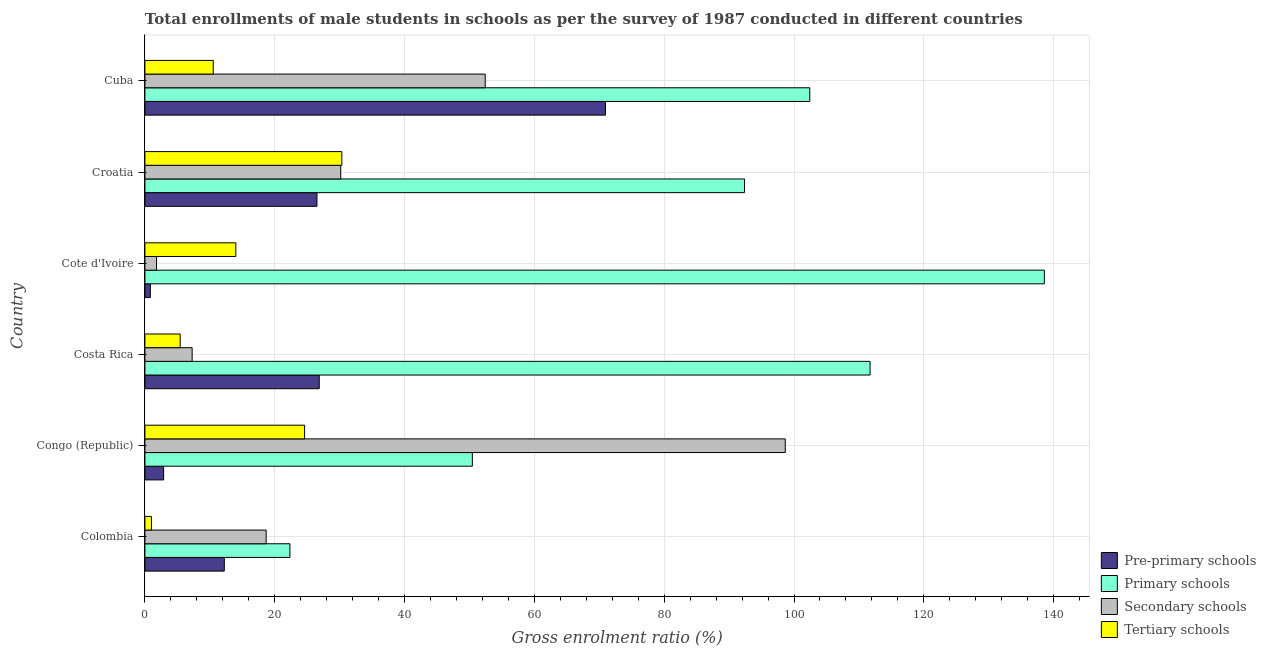How many different coloured bars are there?
Your answer should be very brief. 4. Are the number of bars per tick equal to the number of legend labels?
Provide a short and direct response. Yes. How many bars are there on the 5th tick from the top?
Provide a succinct answer. 4. What is the label of the 6th group of bars from the top?
Offer a terse response. Colombia. In how many cases, is the number of bars for a given country not equal to the number of legend labels?
Offer a very short reply. 0. What is the gross enrolment ratio(male) in primary schools in Costa Rica?
Provide a short and direct response. 111.72. Across all countries, what is the maximum gross enrolment ratio(male) in pre-primary schools?
Give a very brief answer. 70.95. Across all countries, what is the minimum gross enrolment ratio(male) in tertiary schools?
Give a very brief answer. 1. In which country was the gross enrolment ratio(male) in secondary schools maximum?
Provide a short and direct response. Congo (Republic). In which country was the gross enrolment ratio(male) in pre-primary schools minimum?
Ensure brevity in your answer.  Cote d'Ivoire. What is the total gross enrolment ratio(male) in secondary schools in the graph?
Provide a short and direct response. 208.99. What is the difference between the gross enrolment ratio(male) in tertiary schools in Congo (Republic) and that in Cote d'Ivoire?
Provide a succinct answer. 10.59. What is the difference between the gross enrolment ratio(male) in pre-primary schools in Croatia and the gross enrolment ratio(male) in tertiary schools in Cuba?
Make the answer very short. 15.98. What is the average gross enrolment ratio(male) in pre-primary schools per country?
Your response must be concise. 23.38. What is the difference between the gross enrolment ratio(male) in tertiary schools and gross enrolment ratio(male) in primary schools in Cote d'Ivoire?
Your answer should be compact. -124.56. What is the ratio of the gross enrolment ratio(male) in pre-primary schools in Croatia to that in Cuba?
Offer a terse response. 0.37. Is the gross enrolment ratio(male) in secondary schools in Colombia less than that in Croatia?
Your answer should be very brief. Yes. Is the difference between the gross enrolment ratio(male) in secondary schools in Costa Rica and Cuba greater than the difference between the gross enrolment ratio(male) in primary schools in Costa Rica and Cuba?
Keep it short and to the point. No. What is the difference between the highest and the second highest gross enrolment ratio(male) in primary schools?
Provide a short and direct response. 26.85. What is the difference between the highest and the lowest gross enrolment ratio(male) in primary schools?
Provide a short and direct response. 116.23. In how many countries, is the gross enrolment ratio(male) in secondary schools greater than the average gross enrolment ratio(male) in secondary schools taken over all countries?
Provide a succinct answer. 2. Is the sum of the gross enrolment ratio(male) in pre-primary schools in Cote d'Ivoire and Cuba greater than the maximum gross enrolment ratio(male) in secondary schools across all countries?
Your answer should be very brief. No. Is it the case that in every country, the sum of the gross enrolment ratio(male) in tertiary schools and gross enrolment ratio(male) in pre-primary schools is greater than the sum of gross enrolment ratio(male) in primary schools and gross enrolment ratio(male) in secondary schools?
Make the answer very short. No. What does the 1st bar from the top in Cote d'Ivoire represents?
Your answer should be very brief. Tertiary schools. What does the 4th bar from the bottom in Congo (Republic) represents?
Make the answer very short. Tertiary schools. Is it the case that in every country, the sum of the gross enrolment ratio(male) in pre-primary schools and gross enrolment ratio(male) in primary schools is greater than the gross enrolment ratio(male) in secondary schools?
Make the answer very short. No. How many bars are there?
Make the answer very short. 24. Are all the bars in the graph horizontal?
Give a very brief answer. Yes. Are the values on the major ticks of X-axis written in scientific E-notation?
Offer a terse response. No. Where does the legend appear in the graph?
Provide a short and direct response. Bottom right. What is the title of the graph?
Your answer should be very brief. Total enrollments of male students in schools as per the survey of 1987 conducted in different countries. Does "Water" appear as one of the legend labels in the graph?
Your answer should be compact. No. What is the Gross enrolment ratio (%) in Pre-primary schools in Colombia?
Your answer should be compact. 12.23. What is the Gross enrolment ratio (%) of Primary schools in Colombia?
Make the answer very short. 22.34. What is the Gross enrolment ratio (%) in Secondary schools in Colombia?
Keep it short and to the point. 18.68. What is the Gross enrolment ratio (%) of Tertiary schools in Colombia?
Offer a very short reply. 1. What is the Gross enrolment ratio (%) of Pre-primary schools in Congo (Republic)?
Provide a short and direct response. 2.88. What is the Gross enrolment ratio (%) in Primary schools in Congo (Republic)?
Keep it short and to the point. 50.44. What is the Gross enrolment ratio (%) of Secondary schools in Congo (Republic)?
Your response must be concise. 98.65. What is the Gross enrolment ratio (%) in Tertiary schools in Congo (Republic)?
Provide a succinct answer. 24.6. What is the Gross enrolment ratio (%) of Pre-primary schools in Costa Rica?
Offer a terse response. 26.85. What is the Gross enrolment ratio (%) of Primary schools in Costa Rica?
Offer a very short reply. 111.72. What is the Gross enrolment ratio (%) in Secondary schools in Costa Rica?
Provide a short and direct response. 7.27. What is the Gross enrolment ratio (%) in Tertiary schools in Costa Rica?
Your answer should be very brief. 5.43. What is the Gross enrolment ratio (%) of Pre-primary schools in Cote d'Ivoire?
Offer a terse response. 0.84. What is the Gross enrolment ratio (%) in Primary schools in Cote d'Ivoire?
Offer a very short reply. 138.57. What is the Gross enrolment ratio (%) in Secondary schools in Cote d'Ivoire?
Offer a very short reply. 1.79. What is the Gross enrolment ratio (%) of Tertiary schools in Cote d'Ivoire?
Ensure brevity in your answer.  14.01. What is the Gross enrolment ratio (%) of Pre-primary schools in Croatia?
Your response must be concise. 26.51. What is the Gross enrolment ratio (%) in Primary schools in Croatia?
Make the answer very short. 92.38. What is the Gross enrolment ratio (%) in Secondary schools in Croatia?
Your response must be concise. 30.17. What is the Gross enrolment ratio (%) in Tertiary schools in Croatia?
Give a very brief answer. 30.34. What is the Gross enrolment ratio (%) of Pre-primary schools in Cuba?
Make the answer very short. 70.95. What is the Gross enrolment ratio (%) in Primary schools in Cuba?
Your response must be concise. 102.43. What is the Gross enrolment ratio (%) of Secondary schools in Cuba?
Give a very brief answer. 52.43. What is the Gross enrolment ratio (%) of Tertiary schools in Cuba?
Ensure brevity in your answer.  10.53. Across all countries, what is the maximum Gross enrolment ratio (%) in Pre-primary schools?
Your answer should be compact. 70.95. Across all countries, what is the maximum Gross enrolment ratio (%) of Primary schools?
Provide a succinct answer. 138.57. Across all countries, what is the maximum Gross enrolment ratio (%) in Secondary schools?
Offer a terse response. 98.65. Across all countries, what is the maximum Gross enrolment ratio (%) in Tertiary schools?
Make the answer very short. 30.34. Across all countries, what is the minimum Gross enrolment ratio (%) in Pre-primary schools?
Keep it short and to the point. 0.84. Across all countries, what is the minimum Gross enrolment ratio (%) of Primary schools?
Your response must be concise. 22.34. Across all countries, what is the minimum Gross enrolment ratio (%) in Secondary schools?
Keep it short and to the point. 1.79. Across all countries, what is the minimum Gross enrolment ratio (%) in Tertiary schools?
Your answer should be compact. 1. What is the total Gross enrolment ratio (%) in Pre-primary schools in the graph?
Keep it short and to the point. 140.26. What is the total Gross enrolment ratio (%) in Primary schools in the graph?
Your answer should be very brief. 517.87. What is the total Gross enrolment ratio (%) of Secondary schools in the graph?
Your answer should be very brief. 208.99. What is the total Gross enrolment ratio (%) of Tertiary schools in the graph?
Your answer should be very brief. 85.91. What is the difference between the Gross enrolment ratio (%) of Pre-primary schools in Colombia and that in Congo (Republic)?
Offer a terse response. 9.35. What is the difference between the Gross enrolment ratio (%) in Primary schools in Colombia and that in Congo (Republic)?
Keep it short and to the point. -28.1. What is the difference between the Gross enrolment ratio (%) of Secondary schools in Colombia and that in Congo (Republic)?
Ensure brevity in your answer.  -79.97. What is the difference between the Gross enrolment ratio (%) in Tertiary schools in Colombia and that in Congo (Republic)?
Give a very brief answer. -23.59. What is the difference between the Gross enrolment ratio (%) in Pre-primary schools in Colombia and that in Costa Rica?
Provide a succinct answer. -14.62. What is the difference between the Gross enrolment ratio (%) of Primary schools in Colombia and that in Costa Rica?
Make the answer very short. -89.38. What is the difference between the Gross enrolment ratio (%) of Secondary schools in Colombia and that in Costa Rica?
Your answer should be compact. 11.4. What is the difference between the Gross enrolment ratio (%) in Tertiary schools in Colombia and that in Costa Rica?
Make the answer very short. -4.43. What is the difference between the Gross enrolment ratio (%) of Pre-primary schools in Colombia and that in Cote d'Ivoire?
Keep it short and to the point. 11.39. What is the difference between the Gross enrolment ratio (%) of Primary schools in Colombia and that in Cote d'Ivoire?
Offer a very short reply. -116.23. What is the difference between the Gross enrolment ratio (%) in Secondary schools in Colombia and that in Cote d'Ivoire?
Give a very brief answer. 16.89. What is the difference between the Gross enrolment ratio (%) of Tertiary schools in Colombia and that in Cote d'Ivoire?
Give a very brief answer. -13. What is the difference between the Gross enrolment ratio (%) in Pre-primary schools in Colombia and that in Croatia?
Make the answer very short. -14.28. What is the difference between the Gross enrolment ratio (%) of Primary schools in Colombia and that in Croatia?
Your answer should be very brief. -70.04. What is the difference between the Gross enrolment ratio (%) of Secondary schools in Colombia and that in Croatia?
Your answer should be very brief. -11.49. What is the difference between the Gross enrolment ratio (%) in Tertiary schools in Colombia and that in Croatia?
Your answer should be very brief. -29.33. What is the difference between the Gross enrolment ratio (%) in Pre-primary schools in Colombia and that in Cuba?
Your answer should be very brief. -58.72. What is the difference between the Gross enrolment ratio (%) in Primary schools in Colombia and that in Cuba?
Your answer should be very brief. -80.09. What is the difference between the Gross enrolment ratio (%) in Secondary schools in Colombia and that in Cuba?
Keep it short and to the point. -33.75. What is the difference between the Gross enrolment ratio (%) in Tertiary schools in Colombia and that in Cuba?
Your answer should be very brief. -9.52. What is the difference between the Gross enrolment ratio (%) of Pre-primary schools in Congo (Republic) and that in Costa Rica?
Your answer should be very brief. -23.97. What is the difference between the Gross enrolment ratio (%) in Primary schools in Congo (Republic) and that in Costa Rica?
Offer a terse response. -61.27. What is the difference between the Gross enrolment ratio (%) in Secondary schools in Congo (Republic) and that in Costa Rica?
Offer a terse response. 91.38. What is the difference between the Gross enrolment ratio (%) of Tertiary schools in Congo (Republic) and that in Costa Rica?
Ensure brevity in your answer.  19.17. What is the difference between the Gross enrolment ratio (%) of Pre-primary schools in Congo (Republic) and that in Cote d'Ivoire?
Offer a very short reply. 2.05. What is the difference between the Gross enrolment ratio (%) in Primary schools in Congo (Republic) and that in Cote d'Ivoire?
Provide a succinct answer. -88.13. What is the difference between the Gross enrolment ratio (%) of Secondary schools in Congo (Republic) and that in Cote d'Ivoire?
Your answer should be compact. 96.86. What is the difference between the Gross enrolment ratio (%) of Tertiary schools in Congo (Republic) and that in Cote d'Ivoire?
Ensure brevity in your answer.  10.59. What is the difference between the Gross enrolment ratio (%) in Pre-primary schools in Congo (Republic) and that in Croatia?
Your answer should be compact. -23.63. What is the difference between the Gross enrolment ratio (%) in Primary schools in Congo (Republic) and that in Croatia?
Offer a terse response. -41.93. What is the difference between the Gross enrolment ratio (%) in Secondary schools in Congo (Republic) and that in Croatia?
Your answer should be compact. 68.49. What is the difference between the Gross enrolment ratio (%) of Tertiary schools in Congo (Republic) and that in Croatia?
Ensure brevity in your answer.  -5.74. What is the difference between the Gross enrolment ratio (%) of Pre-primary schools in Congo (Republic) and that in Cuba?
Your answer should be compact. -68.07. What is the difference between the Gross enrolment ratio (%) of Primary schools in Congo (Republic) and that in Cuba?
Ensure brevity in your answer.  -51.99. What is the difference between the Gross enrolment ratio (%) of Secondary schools in Congo (Republic) and that in Cuba?
Provide a succinct answer. 46.23. What is the difference between the Gross enrolment ratio (%) of Tertiary schools in Congo (Republic) and that in Cuba?
Your answer should be very brief. 14.07. What is the difference between the Gross enrolment ratio (%) in Pre-primary schools in Costa Rica and that in Cote d'Ivoire?
Provide a succinct answer. 26.02. What is the difference between the Gross enrolment ratio (%) in Primary schools in Costa Rica and that in Cote d'Ivoire?
Offer a very short reply. -26.85. What is the difference between the Gross enrolment ratio (%) of Secondary schools in Costa Rica and that in Cote d'Ivoire?
Your answer should be compact. 5.49. What is the difference between the Gross enrolment ratio (%) of Tertiary schools in Costa Rica and that in Cote d'Ivoire?
Your answer should be very brief. -8.58. What is the difference between the Gross enrolment ratio (%) in Pre-primary schools in Costa Rica and that in Croatia?
Your response must be concise. 0.35. What is the difference between the Gross enrolment ratio (%) of Primary schools in Costa Rica and that in Croatia?
Give a very brief answer. 19.34. What is the difference between the Gross enrolment ratio (%) in Secondary schools in Costa Rica and that in Croatia?
Offer a terse response. -22.89. What is the difference between the Gross enrolment ratio (%) in Tertiary schools in Costa Rica and that in Croatia?
Keep it short and to the point. -24.91. What is the difference between the Gross enrolment ratio (%) in Pre-primary schools in Costa Rica and that in Cuba?
Offer a very short reply. -44.1. What is the difference between the Gross enrolment ratio (%) of Primary schools in Costa Rica and that in Cuba?
Your answer should be very brief. 9.29. What is the difference between the Gross enrolment ratio (%) of Secondary schools in Costa Rica and that in Cuba?
Ensure brevity in your answer.  -45.15. What is the difference between the Gross enrolment ratio (%) of Tertiary schools in Costa Rica and that in Cuba?
Your answer should be very brief. -5.09. What is the difference between the Gross enrolment ratio (%) of Pre-primary schools in Cote d'Ivoire and that in Croatia?
Offer a terse response. -25.67. What is the difference between the Gross enrolment ratio (%) of Primary schools in Cote d'Ivoire and that in Croatia?
Ensure brevity in your answer.  46.19. What is the difference between the Gross enrolment ratio (%) of Secondary schools in Cote d'Ivoire and that in Croatia?
Offer a very short reply. -28.38. What is the difference between the Gross enrolment ratio (%) in Tertiary schools in Cote d'Ivoire and that in Croatia?
Your response must be concise. -16.33. What is the difference between the Gross enrolment ratio (%) in Pre-primary schools in Cote d'Ivoire and that in Cuba?
Provide a succinct answer. -70.12. What is the difference between the Gross enrolment ratio (%) of Primary schools in Cote d'Ivoire and that in Cuba?
Provide a short and direct response. 36.14. What is the difference between the Gross enrolment ratio (%) of Secondary schools in Cote d'Ivoire and that in Cuba?
Provide a succinct answer. -50.64. What is the difference between the Gross enrolment ratio (%) of Tertiary schools in Cote d'Ivoire and that in Cuba?
Make the answer very short. 3.48. What is the difference between the Gross enrolment ratio (%) in Pre-primary schools in Croatia and that in Cuba?
Make the answer very short. -44.45. What is the difference between the Gross enrolment ratio (%) in Primary schools in Croatia and that in Cuba?
Keep it short and to the point. -10.05. What is the difference between the Gross enrolment ratio (%) of Secondary schools in Croatia and that in Cuba?
Your response must be concise. -22.26. What is the difference between the Gross enrolment ratio (%) in Tertiary schools in Croatia and that in Cuba?
Make the answer very short. 19.81. What is the difference between the Gross enrolment ratio (%) in Pre-primary schools in Colombia and the Gross enrolment ratio (%) in Primary schools in Congo (Republic)?
Offer a terse response. -38.21. What is the difference between the Gross enrolment ratio (%) in Pre-primary schools in Colombia and the Gross enrolment ratio (%) in Secondary schools in Congo (Republic)?
Your answer should be very brief. -86.42. What is the difference between the Gross enrolment ratio (%) of Pre-primary schools in Colombia and the Gross enrolment ratio (%) of Tertiary schools in Congo (Republic)?
Your response must be concise. -12.37. What is the difference between the Gross enrolment ratio (%) in Primary schools in Colombia and the Gross enrolment ratio (%) in Secondary schools in Congo (Republic)?
Give a very brief answer. -76.31. What is the difference between the Gross enrolment ratio (%) of Primary schools in Colombia and the Gross enrolment ratio (%) of Tertiary schools in Congo (Republic)?
Provide a succinct answer. -2.26. What is the difference between the Gross enrolment ratio (%) in Secondary schools in Colombia and the Gross enrolment ratio (%) in Tertiary schools in Congo (Republic)?
Your response must be concise. -5.92. What is the difference between the Gross enrolment ratio (%) of Pre-primary schools in Colombia and the Gross enrolment ratio (%) of Primary schools in Costa Rica?
Your response must be concise. -99.49. What is the difference between the Gross enrolment ratio (%) in Pre-primary schools in Colombia and the Gross enrolment ratio (%) in Secondary schools in Costa Rica?
Provide a succinct answer. 4.96. What is the difference between the Gross enrolment ratio (%) of Pre-primary schools in Colombia and the Gross enrolment ratio (%) of Tertiary schools in Costa Rica?
Your answer should be very brief. 6.8. What is the difference between the Gross enrolment ratio (%) in Primary schools in Colombia and the Gross enrolment ratio (%) in Secondary schools in Costa Rica?
Give a very brief answer. 15.06. What is the difference between the Gross enrolment ratio (%) of Primary schools in Colombia and the Gross enrolment ratio (%) of Tertiary schools in Costa Rica?
Offer a very short reply. 16.91. What is the difference between the Gross enrolment ratio (%) of Secondary schools in Colombia and the Gross enrolment ratio (%) of Tertiary schools in Costa Rica?
Offer a very short reply. 13.25. What is the difference between the Gross enrolment ratio (%) in Pre-primary schools in Colombia and the Gross enrolment ratio (%) in Primary schools in Cote d'Ivoire?
Your answer should be very brief. -126.34. What is the difference between the Gross enrolment ratio (%) of Pre-primary schools in Colombia and the Gross enrolment ratio (%) of Secondary schools in Cote d'Ivoire?
Make the answer very short. 10.44. What is the difference between the Gross enrolment ratio (%) in Pre-primary schools in Colombia and the Gross enrolment ratio (%) in Tertiary schools in Cote d'Ivoire?
Offer a terse response. -1.78. What is the difference between the Gross enrolment ratio (%) in Primary schools in Colombia and the Gross enrolment ratio (%) in Secondary schools in Cote d'Ivoire?
Your answer should be compact. 20.55. What is the difference between the Gross enrolment ratio (%) of Primary schools in Colombia and the Gross enrolment ratio (%) of Tertiary schools in Cote d'Ivoire?
Make the answer very short. 8.33. What is the difference between the Gross enrolment ratio (%) in Secondary schools in Colombia and the Gross enrolment ratio (%) in Tertiary schools in Cote d'Ivoire?
Provide a short and direct response. 4.67. What is the difference between the Gross enrolment ratio (%) of Pre-primary schools in Colombia and the Gross enrolment ratio (%) of Primary schools in Croatia?
Keep it short and to the point. -80.15. What is the difference between the Gross enrolment ratio (%) in Pre-primary schools in Colombia and the Gross enrolment ratio (%) in Secondary schools in Croatia?
Your response must be concise. -17.94. What is the difference between the Gross enrolment ratio (%) of Pre-primary schools in Colombia and the Gross enrolment ratio (%) of Tertiary schools in Croatia?
Offer a very short reply. -18.11. What is the difference between the Gross enrolment ratio (%) in Primary schools in Colombia and the Gross enrolment ratio (%) in Secondary schools in Croatia?
Give a very brief answer. -7.83. What is the difference between the Gross enrolment ratio (%) in Primary schools in Colombia and the Gross enrolment ratio (%) in Tertiary schools in Croatia?
Your answer should be very brief. -8. What is the difference between the Gross enrolment ratio (%) of Secondary schools in Colombia and the Gross enrolment ratio (%) of Tertiary schools in Croatia?
Give a very brief answer. -11.66. What is the difference between the Gross enrolment ratio (%) of Pre-primary schools in Colombia and the Gross enrolment ratio (%) of Primary schools in Cuba?
Keep it short and to the point. -90.2. What is the difference between the Gross enrolment ratio (%) of Pre-primary schools in Colombia and the Gross enrolment ratio (%) of Secondary schools in Cuba?
Your answer should be very brief. -40.2. What is the difference between the Gross enrolment ratio (%) in Pre-primary schools in Colombia and the Gross enrolment ratio (%) in Tertiary schools in Cuba?
Your answer should be compact. 1.7. What is the difference between the Gross enrolment ratio (%) in Primary schools in Colombia and the Gross enrolment ratio (%) in Secondary schools in Cuba?
Make the answer very short. -30.09. What is the difference between the Gross enrolment ratio (%) in Primary schools in Colombia and the Gross enrolment ratio (%) in Tertiary schools in Cuba?
Your answer should be compact. 11.81. What is the difference between the Gross enrolment ratio (%) of Secondary schools in Colombia and the Gross enrolment ratio (%) of Tertiary schools in Cuba?
Ensure brevity in your answer.  8.15. What is the difference between the Gross enrolment ratio (%) of Pre-primary schools in Congo (Republic) and the Gross enrolment ratio (%) of Primary schools in Costa Rica?
Offer a terse response. -108.83. What is the difference between the Gross enrolment ratio (%) of Pre-primary schools in Congo (Republic) and the Gross enrolment ratio (%) of Secondary schools in Costa Rica?
Keep it short and to the point. -4.39. What is the difference between the Gross enrolment ratio (%) of Pre-primary schools in Congo (Republic) and the Gross enrolment ratio (%) of Tertiary schools in Costa Rica?
Ensure brevity in your answer.  -2.55. What is the difference between the Gross enrolment ratio (%) of Primary schools in Congo (Republic) and the Gross enrolment ratio (%) of Secondary schools in Costa Rica?
Provide a short and direct response. 43.17. What is the difference between the Gross enrolment ratio (%) in Primary schools in Congo (Republic) and the Gross enrolment ratio (%) in Tertiary schools in Costa Rica?
Give a very brief answer. 45.01. What is the difference between the Gross enrolment ratio (%) of Secondary schools in Congo (Republic) and the Gross enrolment ratio (%) of Tertiary schools in Costa Rica?
Your answer should be very brief. 93.22. What is the difference between the Gross enrolment ratio (%) in Pre-primary schools in Congo (Republic) and the Gross enrolment ratio (%) in Primary schools in Cote d'Ivoire?
Provide a short and direct response. -135.69. What is the difference between the Gross enrolment ratio (%) in Pre-primary schools in Congo (Republic) and the Gross enrolment ratio (%) in Secondary schools in Cote d'Ivoire?
Your answer should be very brief. 1.09. What is the difference between the Gross enrolment ratio (%) of Pre-primary schools in Congo (Republic) and the Gross enrolment ratio (%) of Tertiary schools in Cote d'Ivoire?
Make the answer very short. -11.13. What is the difference between the Gross enrolment ratio (%) of Primary schools in Congo (Republic) and the Gross enrolment ratio (%) of Secondary schools in Cote d'Ivoire?
Your response must be concise. 48.65. What is the difference between the Gross enrolment ratio (%) of Primary schools in Congo (Republic) and the Gross enrolment ratio (%) of Tertiary schools in Cote d'Ivoire?
Offer a terse response. 36.44. What is the difference between the Gross enrolment ratio (%) in Secondary schools in Congo (Republic) and the Gross enrolment ratio (%) in Tertiary schools in Cote d'Ivoire?
Offer a very short reply. 84.65. What is the difference between the Gross enrolment ratio (%) in Pre-primary schools in Congo (Republic) and the Gross enrolment ratio (%) in Primary schools in Croatia?
Ensure brevity in your answer.  -89.5. What is the difference between the Gross enrolment ratio (%) in Pre-primary schools in Congo (Republic) and the Gross enrolment ratio (%) in Secondary schools in Croatia?
Give a very brief answer. -27.29. What is the difference between the Gross enrolment ratio (%) in Pre-primary schools in Congo (Republic) and the Gross enrolment ratio (%) in Tertiary schools in Croatia?
Make the answer very short. -27.46. What is the difference between the Gross enrolment ratio (%) in Primary schools in Congo (Republic) and the Gross enrolment ratio (%) in Secondary schools in Croatia?
Your response must be concise. 20.27. What is the difference between the Gross enrolment ratio (%) in Primary schools in Congo (Republic) and the Gross enrolment ratio (%) in Tertiary schools in Croatia?
Ensure brevity in your answer.  20.1. What is the difference between the Gross enrolment ratio (%) of Secondary schools in Congo (Republic) and the Gross enrolment ratio (%) of Tertiary schools in Croatia?
Keep it short and to the point. 68.31. What is the difference between the Gross enrolment ratio (%) of Pre-primary schools in Congo (Republic) and the Gross enrolment ratio (%) of Primary schools in Cuba?
Ensure brevity in your answer.  -99.55. What is the difference between the Gross enrolment ratio (%) in Pre-primary schools in Congo (Republic) and the Gross enrolment ratio (%) in Secondary schools in Cuba?
Provide a short and direct response. -49.55. What is the difference between the Gross enrolment ratio (%) in Pre-primary schools in Congo (Republic) and the Gross enrolment ratio (%) in Tertiary schools in Cuba?
Ensure brevity in your answer.  -7.65. What is the difference between the Gross enrolment ratio (%) of Primary schools in Congo (Republic) and the Gross enrolment ratio (%) of Secondary schools in Cuba?
Provide a succinct answer. -1.98. What is the difference between the Gross enrolment ratio (%) of Primary schools in Congo (Republic) and the Gross enrolment ratio (%) of Tertiary schools in Cuba?
Your response must be concise. 39.92. What is the difference between the Gross enrolment ratio (%) of Secondary schools in Congo (Republic) and the Gross enrolment ratio (%) of Tertiary schools in Cuba?
Provide a succinct answer. 88.13. What is the difference between the Gross enrolment ratio (%) of Pre-primary schools in Costa Rica and the Gross enrolment ratio (%) of Primary schools in Cote d'Ivoire?
Ensure brevity in your answer.  -111.72. What is the difference between the Gross enrolment ratio (%) of Pre-primary schools in Costa Rica and the Gross enrolment ratio (%) of Secondary schools in Cote d'Ivoire?
Your answer should be very brief. 25.06. What is the difference between the Gross enrolment ratio (%) of Pre-primary schools in Costa Rica and the Gross enrolment ratio (%) of Tertiary schools in Cote d'Ivoire?
Ensure brevity in your answer.  12.85. What is the difference between the Gross enrolment ratio (%) of Primary schools in Costa Rica and the Gross enrolment ratio (%) of Secondary schools in Cote d'Ivoire?
Keep it short and to the point. 109.93. What is the difference between the Gross enrolment ratio (%) of Primary schools in Costa Rica and the Gross enrolment ratio (%) of Tertiary schools in Cote d'Ivoire?
Offer a very short reply. 97.71. What is the difference between the Gross enrolment ratio (%) in Secondary schools in Costa Rica and the Gross enrolment ratio (%) in Tertiary schools in Cote d'Ivoire?
Offer a very short reply. -6.73. What is the difference between the Gross enrolment ratio (%) in Pre-primary schools in Costa Rica and the Gross enrolment ratio (%) in Primary schools in Croatia?
Provide a short and direct response. -65.52. What is the difference between the Gross enrolment ratio (%) in Pre-primary schools in Costa Rica and the Gross enrolment ratio (%) in Secondary schools in Croatia?
Offer a terse response. -3.31. What is the difference between the Gross enrolment ratio (%) of Pre-primary schools in Costa Rica and the Gross enrolment ratio (%) of Tertiary schools in Croatia?
Offer a very short reply. -3.48. What is the difference between the Gross enrolment ratio (%) of Primary schools in Costa Rica and the Gross enrolment ratio (%) of Secondary schools in Croatia?
Your answer should be compact. 81.55. What is the difference between the Gross enrolment ratio (%) of Primary schools in Costa Rica and the Gross enrolment ratio (%) of Tertiary schools in Croatia?
Ensure brevity in your answer.  81.38. What is the difference between the Gross enrolment ratio (%) of Secondary schools in Costa Rica and the Gross enrolment ratio (%) of Tertiary schools in Croatia?
Your response must be concise. -23.06. What is the difference between the Gross enrolment ratio (%) in Pre-primary schools in Costa Rica and the Gross enrolment ratio (%) in Primary schools in Cuba?
Offer a terse response. -75.57. What is the difference between the Gross enrolment ratio (%) of Pre-primary schools in Costa Rica and the Gross enrolment ratio (%) of Secondary schools in Cuba?
Provide a short and direct response. -25.57. What is the difference between the Gross enrolment ratio (%) of Pre-primary schools in Costa Rica and the Gross enrolment ratio (%) of Tertiary schools in Cuba?
Ensure brevity in your answer.  16.33. What is the difference between the Gross enrolment ratio (%) of Primary schools in Costa Rica and the Gross enrolment ratio (%) of Secondary schools in Cuba?
Your answer should be compact. 59.29. What is the difference between the Gross enrolment ratio (%) in Primary schools in Costa Rica and the Gross enrolment ratio (%) in Tertiary schools in Cuba?
Keep it short and to the point. 101.19. What is the difference between the Gross enrolment ratio (%) in Secondary schools in Costa Rica and the Gross enrolment ratio (%) in Tertiary schools in Cuba?
Your answer should be very brief. -3.25. What is the difference between the Gross enrolment ratio (%) of Pre-primary schools in Cote d'Ivoire and the Gross enrolment ratio (%) of Primary schools in Croatia?
Your response must be concise. -91.54. What is the difference between the Gross enrolment ratio (%) of Pre-primary schools in Cote d'Ivoire and the Gross enrolment ratio (%) of Secondary schools in Croatia?
Offer a terse response. -29.33. What is the difference between the Gross enrolment ratio (%) of Pre-primary schools in Cote d'Ivoire and the Gross enrolment ratio (%) of Tertiary schools in Croatia?
Provide a short and direct response. -29.5. What is the difference between the Gross enrolment ratio (%) in Primary schools in Cote d'Ivoire and the Gross enrolment ratio (%) in Secondary schools in Croatia?
Make the answer very short. 108.4. What is the difference between the Gross enrolment ratio (%) of Primary schools in Cote d'Ivoire and the Gross enrolment ratio (%) of Tertiary schools in Croatia?
Your answer should be very brief. 108.23. What is the difference between the Gross enrolment ratio (%) in Secondary schools in Cote d'Ivoire and the Gross enrolment ratio (%) in Tertiary schools in Croatia?
Ensure brevity in your answer.  -28.55. What is the difference between the Gross enrolment ratio (%) of Pre-primary schools in Cote d'Ivoire and the Gross enrolment ratio (%) of Primary schools in Cuba?
Keep it short and to the point. -101.59. What is the difference between the Gross enrolment ratio (%) of Pre-primary schools in Cote d'Ivoire and the Gross enrolment ratio (%) of Secondary schools in Cuba?
Offer a terse response. -51.59. What is the difference between the Gross enrolment ratio (%) in Pre-primary schools in Cote d'Ivoire and the Gross enrolment ratio (%) in Tertiary schools in Cuba?
Ensure brevity in your answer.  -9.69. What is the difference between the Gross enrolment ratio (%) in Primary schools in Cote d'Ivoire and the Gross enrolment ratio (%) in Secondary schools in Cuba?
Your answer should be very brief. 86.14. What is the difference between the Gross enrolment ratio (%) of Primary schools in Cote d'Ivoire and the Gross enrolment ratio (%) of Tertiary schools in Cuba?
Offer a terse response. 128.04. What is the difference between the Gross enrolment ratio (%) of Secondary schools in Cote d'Ivoire and the Gross enrolment ratio (%) of Tertiary schools in Cuba?
Your response must be concise. -8.74. What is the difference between the Gross enrolment ratio (%) in Pre-primary schools in Croatia and the Gross enrolment ratio (%) in Primary schools in Cuba?
Provide a short and direct response. -75.92. What is the difference between the Gross enrolment ratio (%) of Pre-primary schools in Croatia and the Gross enrolment ratio (%) of Secondary schools in Cuba?
Offer a terse response. -25.92. What is the difference between the Gross enrolment ratio (%) in Pre-primary schools in Croatia and the Gross enrolment ratio (%) in Tertiary schools in Cuba?
Ensure brevity in your answer.  15.98. What is the difference between the Gross enrolment ratio (%) in Primary schools in Croatia and the Gross enrolment ratio (%) in Secondary schools in Cuba?
Ensure brevity in your answer.  39.95. What is the difference between the Gross enrolment ratio (%) of Primary schools in Croatia and the Gross enrolment ratio (%) of Tertiary schools in Cuba?
Your answer should be compact. 81.85. What is the difference between the Gross enrolment ratio (%) of Secondary schools in Croatia and the Gross enrolment ratio (%) of Tertiary schools in Cuba?
Provide a succinct answer. 19.64. What is the average Gross enrolment ratio (%) in Pre-primary schools per country?
Offer a terse response. 23.38. What is the average Gross enrolment ratio (%) of Primary schools per country?
Give a very brief answer. 86.31. What is the average Gross enrolment ratio (%) of Secondary schools per country?
Your response must be concise. 34.83. What is the average Gross enrolment ratio (%) in Tertiary schools per country?
Provide a succinct answer. 14.32. What is the difference between the Gross enrolment ratio (%) in Pre-primary schools and Gross enrolment ratio (%) in Primary schools in Colombia?
Your answer should be compact. -10.11. What is the difference between the Gross enrolment ratio (%) of Pre-primary schools and Gross enrolment ratio (%) of Secondary schools in Colombia?
Your answer should be compact. -6.45. What is the difference between the Gross enrolment ratio (%) of Pre-primary schools and Gross enrolment ratio (%) of Tertiary schools in Colombia?
Your answer should be compact. 11.23. What is the difference between the Gross enrolment ratio (%) of Primary schools and Gross enrolment ratio (%) of Secondary schools in Colombia?
Offer a very short reply. 3.66. What is the difference between the Gross enrolment ratio (%) in Primary schools and Gross enrolment ratio (%) in Tertiary schools in Colombia?
Offer a terse response. 21.33. What is the difference between the Gross enrolment ratio (%) of Secondary schools and Gross enrolment ratio (%) of Tertiary schools in Colombia?
Your response must be concise. 17.67. What is the difference between the Gross enrolment ratio (%) of Pre-primary schools and Gross enrolment ratio (%) of Primary schools in Congo (Republic)?
Offer a terse response. -47.56. What is the difference between the Gross enrolment ratio (%) of Pre-primary schools and Gross enrolment ratio (%) of Secondary schools in Congo (Republic)?
Provide a succinct answer. -95.77. What is the difference between the Gross enrolment ratio (%) in Pre-primary schools and Gross enrolment ratio (%) in Tertiary schools in Congo (Republic)?
Offer a terse response. -21.72. What is the difference between the Gross enrolment ratio (%) of Primary schools and Gross enrolment ratio (%) of Secondary schools in Congo (Republic)?
Provide a short and direct response. -48.21. What is the difference between the Gross enrolment ratio (%) in Primary schools and Gross enrolment ratio (%) in Tertiary schools in Congo (Republic)?
Your answer should be compact. 25.84. What is the difference between the Gross enrolment ratio (%) of Secondary schools and Gross enrolment ratio (%) of Tertiary schools in Congo (Republic)?
Give a very brief answer. 74.05. What is the difference between the Gross enrolment ratio (%) in Pre-primary schools and Gross enrolment ratio (%) in Primary schools in Costa Rica?
Provide a short and direct response. -84.86. What is the difference between the Gross enrolment ratio (%) of Pre-primary schools and Gross enrolment ratio (%) of Secondary schools in Costa Rica?
Your response must be concise. 19.58. What is the difference between the Gross enrolment ratio (%) in Pre-primary schools and Gross enrolment ratio (%) in Tertiary schools in Costa Rica?
Keep it short and to the point. 21.42. What is the difference between the Gross enrolment ratio (%) of Primary schools and Gross enrolment ratio (%) of Secondary schools in Costa Rica?
Provide a succinct answer. 104.44. What is the difference between the Gross enrolment ratio (%) in Primary schools and Gross enrolment ratio (%) in Tertiary schools in Costa Rica?
Provide a short and direct response. 106.28. What is the difference between the Gross enrolment ratio (%) of Secondary schools and Gross enrolment ratio (%) of Tertiary schools in Costa Rica?
Offer a very short reply. 1.84. What is the difference between the Gross enrolment ratio (%) of Pre-primary schools and Gross enrolment ratio (%) of Primary schools in Cote d'Ivoire?
Offer a very short reply. -137.73. What is the difference between the Gross enrolment ratio (%) in Pre-primary schools and Gross enrolment ratio (%) in Secondary schools in Cote d'Ivoire?
Your response must be concise. -0.95. What is the difference between the Gross enrolment ratio (%) in Pre-primary schools and Gross enrolment ratio (%) in Tertiary schools in Cote d'Ivoire?
Ensure brevity in your answer.  -13.17. What is the difference between the Gross enrolment ratio (%) of Primary schools and Gross enrolment ratio (%) of Secondary schools in Cote d'Ivoire?
Give a very brief answer. 136.78. What is the difference between the Gross enrolment ratio (%) of Primary schools and Gross enrolment ratio (%) of Tertiary schools in Cote d'Ivoire?
Make the answer very short. 124.56. What is the difference between the Gross enrolment ratio (%) in Secondary schools and Gross enrolment ratio (%) in Tertiary schools in Cote d'Ivoire?
Provide a succinct answer. -12.22. What is the difference between the Gross enrolment ratio (%) in Pre-primary schools and Gross enrolment ratio (%) in Primary schools in Croatia?
Provide a short and direct response. -65.87. What is the difference between the Gross enrolment ratio (%) of Pre-primary schools and Gross enrolment ratio (%) of Secondary schools in Croatia?
Provide a succinct answer. -3.66. What is the difference between the Gross enrolment ratio (%) in Pre-primary schools and Gross enrolment ratio (%) in Tertiary schools in Croatia?
Make the answer very short. -3.83. What is the difference between the Gross enrolment ratio (%) in Primary schools and Gross enrolment ratio (%) in Secondary schools in Croatia?
Provide a short and direct response. 62.21. What is the difference between the Gross enrolment ratio (%) of Primary schools and Gross enrolment ratio (%) of Tertiary schools in Croatia?
Offer a terse response. 62.04. What is the difference between the Gross enrolment ratio (%) in Secondary schools and Gross enrolment ratio (%) in Tertiary schools in Croatia?
Provide a succinct answer. -0.17. What is the difference between the Gross enrolment ratio (%) in Pre-primary schools and Gross enrolment ratio (%) in Primary schools in Cuba?
Ensure brevity in your answer.  -31.47. What is the difference between the Gross enrolment ratio (%) in Pre-primary schools and Gross enrolment ratio (%) in Secondary schools in Cuba?
Your answer should be compact. 18.53. What is the difference between the Gross enrolment ratio (%) in Pre-primary schools and Gross enrolment ratio (%) in Tertiary schools in Cuba?
Provide a short and direct response. 60.43. What is the difference between the Gross enrolment ratio (%) in Primary schools and Gross enrolment ratio (%) in Secondary schools in Cuba?
Provide a succinct answer. 50. What is the difference between the Gross enrolment ratio (%) in Primary schools and Gross enrolment ratio (%) in Tertiary schools in Cuba?
Give a very brief answer. 91.9. What is the difference between the Gross enrolment ratio (%) in Secondary schools and Gross enrolment ratio (%) in Tertiary schools in Cuba?
Your answer should be very brief. 41.9. What is the ratio of the Gross enrolment ratio (%) in Pre-primary schools in Colombia to that in Congo (Republic)?
Provide a short and direct response. 4.25. What is the ratio of the Gross enrolment ratio (%) in Primary schools in Colombia to that in Congo (Republic)?
Keep it short and to the point. 0.44. What is the ratio of the Gross enrolment ratio (%) of Secondary schools in Colombia to that in Congo (Republic)?
Provide a short and direct response. 0.19. What is the ratio of the Gross enrolment ratio (%) of Tertiary schools in Colombia to that in Congo (Republic)?
Provide a short and direct response. 0.04. What is the ratio of the Gross enrolment ratio (%) of Pre-primary schools in Colombia to that in Costa Rica?
Provide a short and direct response. 0.46. What is the ratio of the Gross enrolment ratio (%) of Secondary schools in Colombia to that in Costa Rica?
Make the answer very short. 2.57. What is the ratio of the Gross enrolment ratio (%) of Tertiary schools in Colombia to that in Costa Rica?
Your answer should be very brief. 0.18. What is the ratio of the Gross enrolment ratio (%) in Pre-primary schools in Colombia to that in Cote d'Ivoire?
Ensure brevity in your answer.  14.63. What is the ratio of the Gross enrolment ratio (%) in Primary schools in Colombia to that in Cote d'Ivoire?
Offer a very short reply. 0.16. What is the ratio of the Gross enrolment ratio (%) of Secondary schools in Colombia to that in Cote d'Ivoire?
Your answer should be very brief. 10.44. What is the ratio of the Gross enrolment ratio (%) in Tertiary schools in Colombia to that in Cote d'Ivoire?
Ensure brevity in your answer.  0.07. What is the ratio of the Gross enrolment ratio (%) of Pre-primary schools in Colombia to that in Croatia?
Give a very brief answer. 0.46. What is the ratio of the Gross enrolment ratio (%) of Primary schools in Colombia to that in Croatia?
Provide a succinct answer. 0.24. What is the ratio of the Gross enrolment ratio (%) of Secondary schools in Colombia to that in Croatia?
Give a very brief answer. 0.62. What is the ratio of the Gross enrolment ratio (%) of Tertiary schools in Colombia to that in Croatia?
Give a very brief answer. 0.03. What is the ratio of the Gross enrolment ratio (%) of Pre-primary schools in Colombia to that in Cuba?
Your response must be concise. 0.17. What is the ratio of the Gross enrolment ratio (%) in Primary schools in Colombia to that in Cuba?
Give a very brief answer. 0.22. What is the ratio of the Gross enrolment ratio (%) in Secondary schools in Colombia to that in Cuba?
Provide a succinct answer. 0.36. What is the ratio of the Gross enrolment ratio (%) in Tertiary schools in Colombia to that in Cuba?
Provide a succinct answer. 0.1. What is the ratio of the Gross enrolment ratio (%) of Pre-primary schools in Congo (Republic) to that in Costa Rica?
Offer a very short reply. 0.11. What is the ratio of the Gross enrolment ratio (%) in Primary schools in Congo (Republic) to that in Costa Rica?
Offer a terse response. 0.45. What is the ratio of the Gross enrolment ratio (%) in Secondary schools in Congo (Republic) to that in Costa Rica?
Provide a succinct answer. 13.56. What is the ratio of the Gross enrolment ratio (%) of Tertiary schools in Congo (Republic) to that in Costa Rica?
Offer a terse response. 4.53. What is the ratio of the Gross enrolment ratio (%) of Pre-primary schools in Congo (Republic) to that in Cote d'Ivoire?
Ensure brevity in your answer.  3.45. What is the ratio of the Gross enrolment ratio (%) in Primary schools in Congo (Republic) to that in Cote d'Ivoire?
Your response must be concise. 0.36. What is the ratio of the Gross enrolment ratio (%) of Secondary schools in Congo (Republic) to that in Cote d'Ivoire?
Give a very brief answer. 55.13. What is the ratio of the Gross enrolment ratio (%) in Tertiary schools in Congo (Republic) to that in Cote d'Ivoire?
Make the answer very short. 1.76. What is the ratio of the Gross enrolment ratio (%) in Pre-primary schools in Congo (Republic) to that in Croatia?
Provide a succinct answer. 0.11. What is the ratio of the Gross enrolment ratio (%) of Primary schools in Congo (Republic) to that in Croatia?
Keep it short and to the point. 0.55. What is the ratio of the Gross enrolment ratio (%) in Secondary schools in Congo (Republic) to that in Croatia?
Offer a terse response. 3.27. What is the ratio of the Gross enrolment ratio (%) in Tertiary schools in Congo (Republic) to that in Croatia?
Ensure brevity in your answer.  0.81. What is the ratio of the Gross enrolment ratio (%) of Pre-primary schools in Congo (Republic) to that in Cuba?
Make the answer very short. 0.04. What is the ratio of the Gross enrolment ratio (%) of Primary schools in Congo (Republic) to that in Cuba?
Make the answer very short. 0.49. What is the ratio of the Gross enrolment ratio (%) in Secondary schools in Congo (Republic) to that in Cuba?
Make the answer very short. 1.88. What is the ratio of the Gross enrolment ratio (%) of Tertiary schools in Congo (Republic) to that in Cuba?
Offer a terse response. 2.34. What is the ratio of the Gross enrolment ratio (%) in Pre-primary schools in Costa Rica to that in Cote d'Ivoire?
Make the answer very short. 32.13. What is the ratio of the Gross enrolment ratio (%) in Primary schools in Costa Rica to that in Cote d'Ivoire?
Your answer should be compact. 0.81. What is the ratio of the Gross enrolment ratio (%) in Secondary schools in Costa Rica to that in Cote d'Ivoire?
Make the answer very short. 4.07. What is the ratio of the Gross enrolment ratio (%) of Tertiary schools in Costa Rica to that in Cote d'Ivoire?
Provide a succinct answer. 0.39. What is the ratio of the Gross enrolment ratio (%) in Pre-primary schools in Costa Rica to that in Croatia?
Your response must be concise. 1.01. What is the ratio of the Gross enrolment ratio (%) of Primary schools in Costa Rica to that in Croatia?
Give a very brief answer. 1.21. What is the ratio of the Gross enrolment ratio (%) in Secondary schools in Costa Rica to that in Croatia?
Provide a short and direct response. 0.24. What is the ratio of the Gross enrolment ratio (%) in Tertiary schools in Costa Rica to that in Croatia?
Your response must be concise. 0.18. What is the ratio of the Gross enrolment ratio (%) of Pre-primary schools in Costa Rica to that in Cuba?
Provide a succinct answer. 0.38. What is the ratio of the Gross enrolment ratio (%) in Primary schools in Costa Rica to that in Cuba?
Give a very brief answer. 1.09. What is the ratio of the Gross enrolment ratio (%) in Secondary schools in Costa Rica to that in Cuba?
Your answer should be compact. 0.14. What is the ratio of the Gross enrolment ratio (%) in Tertiary schools in Costa Rica to that in Cuba?
Your answer should be compact. 0.52. What is the ratio of the Gross enrolment ratio (%) in Pre-primary schools in Cote d'Ivoire to that in Croatia?
Make the answer very short. 0.03. What is the ratio of the Gross enrolment ratio (%) of Primary schools in Cote d'Ivoire to that in Croatia?
Provide a succinct answer. 1.5. What is the ratio of the Gross enrolment ratio (%) in Secondary schools in Cote d'Ivoire to that in Croatia?
Give a very brief answer. 0.06. What is the ratio of the Gross enrolment ratio (%) of Tertiary schools in Cote d'Ivoire to that in Croatia?
Ensure brevity in your answer.  0.46. What is the ratio of the Gross enrolment ratio (%) in Pre-primary schools in Cote d'Ivoire to that in Cuba?
Offer a terse response. 0.01. What is the ratio of the Gross enrolment ratio (%) of Primary schools in Cote d'Ivoire to that in Cuba?
Your response must be concise. 1.35. What is the ratio of the Gross enrolment ratio (%) in Secondary schools in Cote d'Ivoire to that in Cuba?
Provide a succinct answer. 0.03. What is the ratio of the Gross enrolment ratio (%) of Tertiary schools in Cote d'Ivoire to that in Cuba?
Your response must be concise. 1.33. What is the ratio of the Gross enrolment ratio (%) in Pre-primary schools in Croatia to that in Cuba?
Make the answer very short. 0.37. What is the ratio of the Gross enrolment ratio (%) of Primary schools in Croatia to that in Cuba?
Keep it short and to the point. 0.9. What is the ratio of the Gross enrolment ratio (%) in Secondary schools in Croatia to that in Cuba?
Keep it short and to the point. 0.58. What is the ratio of the Gross enrolment ratio (%) in Tertiary schools in Croatia to that in Cuba?
Give a very brief answer. 2.88. What is the difference between the highest and the second highest Gross enrolment ratio (%) in Pre-primary schools?
Your answer should be very brief. 44.1. What is the difference between the highest and the second highest Gross enrolment ratio (%) in Primary schools?
Give a very brief answer. 26.85. What is the difference between the highest and the second highest Gross enrolment ratio (%) in Secondary schools?
Your response must be concise. 46.23. What is the difference between the highest and the second highest Gross enrolment ratio (%) in Tertiary schools?
Your answer should be very brief. 5.74. What is the difference between the highest and the lowest Gross enrolment ratio (%) of Pre-primary schools?
Keep it short and to the point. 70.12. What is the difference between the highest and the lowest Gross enrolment ratio (%) in Primary schools?
Your response must be concise. 116.23. What is the difference between the highest and the lowest Gross enrolment ratio (%) in Secondary schools?
Your answer should be compact. 96.86. What is the difference between the highest and the lowest Gross enrolment ratio (%) in Tertiary schools?
Give a very brief answer. 29.33. 